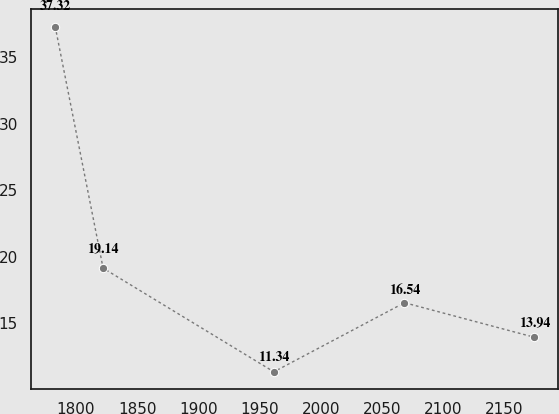Convert chart to OTSL. <chart><loc_0><loc_0><loc_500><loc_500><line_chart><ecel><fcel>Unnamed: 1<nl><fcel>1783.12<fcel>37.32<nl><fcel>1822.25<fcel>19.14<nl><fcel>1961.73<fcel>11.34<nl><fcel>2068.42<fcel>16.54<nl><fcel>2174.47<fcel>13.94<nl></chart> 